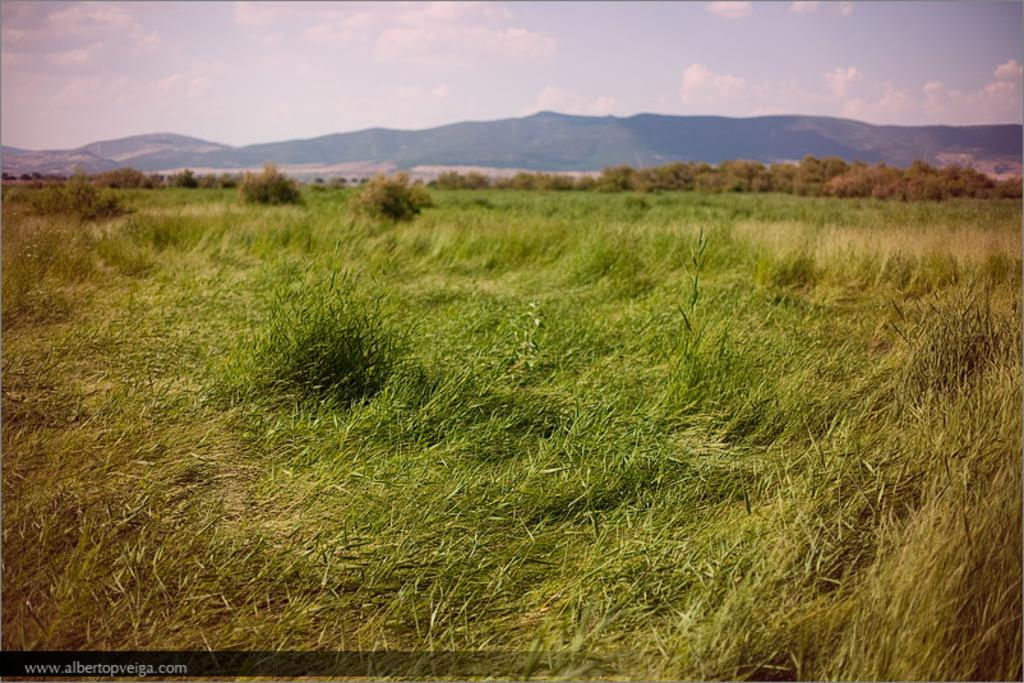What type of surface is visible in the image? There is grass on the surface in the image. What can be seen in the distance in the image? There are mountains visible in the background of the image. What time is displayed on the clock in the image? There is no clock present in the image. What type of stew is being prepared in the image? There is no stew or cooking activity present in the image. 